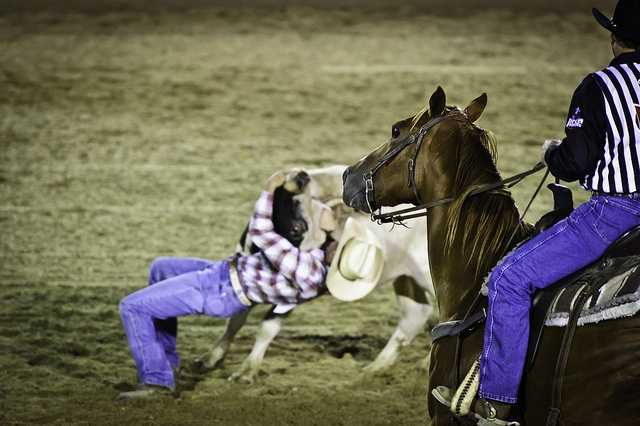Describe the objects in this image and their specific colors. I can see horse in black, olive, and gray tones, people in black, blue, and darkblue tones, people in black, lightgray, violet, blue, and darkgray tones, and cow in black, darkgray, lightgray, and olive tones in this image. 